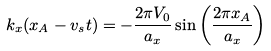Convert formula to latex. <formula><loc_0><loc_0><loc_500><loc_500>k _ { x } ( x _ { A } - v _ { s } t ) = - \frac { 2 \pi V _ { 0 } } { a _ { x } } \sin \left ( \frac { 2 \pi x _ { A } } { a _ { x } } \right )</formula> 